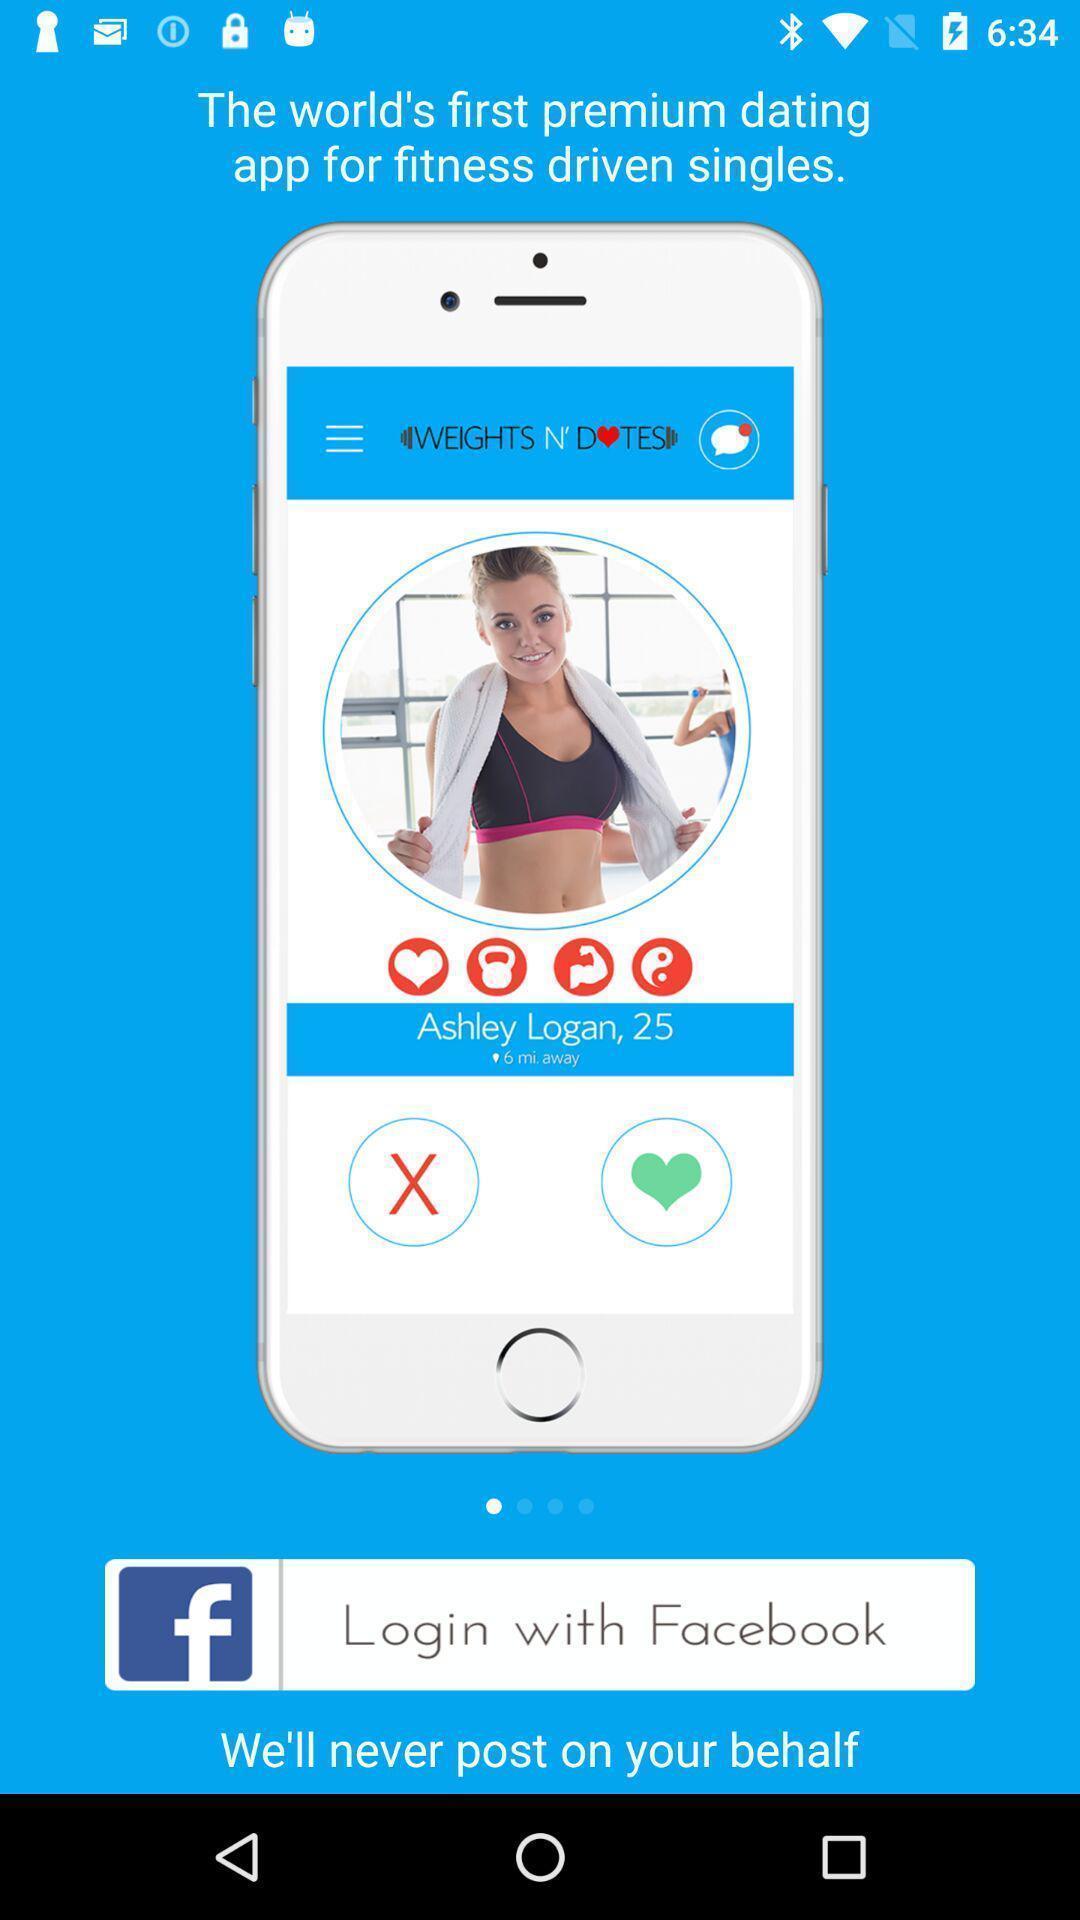Summarize the information in this screenshot. Window displaying fitness dating app. 